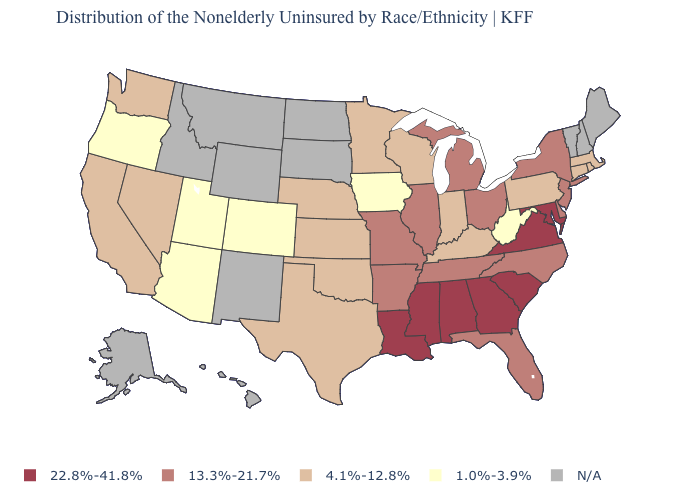Does West Virginia have the lowest value in the South?
Write a very short answer. Yes. Name the states that have a value in the range 4.1%-12.8%?
Concise answer only. California, Connecticut, Indiana, Kansas, Kentucky, Massachusetts, Minnesota, Nebraska, Nevada, Oklahoma, Pennsylvania, Rhode Island, Texas, Washington, Wisconsin. Which states have the lowest value in the West?
Be succinct. Arizona, Colorado, Oregon, Utah. What is the value of Wisconsin?
Concise answer only. 4.1%-12.8%. Does California have the lowest value in the West?
Be succinct. No. Which states have the highest value in the USA?
Concise answer only. Alabama, Georgia, Louisiana, Maryland, Mississippi, South Carolina, Virginia. What is the highest value in the South ?
Keep it brief. 22.8%-41.8%. Is the legend a continuous bar?
Write a very short answer. No. What is the value of Louisiana?
Give a very brief answer. 22.8%-41.8%. Name the states that have a value in the range N/A?
Be succinct. Alaska, Hawaii, Idaho, Maine, Montana, New Hampshire, New Mexico, North Dakota, South Dakota, Vermont, Wyoming. Which states have the lowest value in the USA?
Keep it brief. Arizona, Colorado, Iowa, Oregon, Utah, West Virginia. Name the states that have a value in the range 22.8%-41.8%?
Concise answer only. Alabama, Georgia, Louisiana, Maryland, Mississippi, South Carolina, Virginia. What is the value of South Carolina?
Quick response, please. 22.8%-41.8%. Which states have the lowest value in the USA?
Answer briefly. Arizona, Colorado, Iowa, Oregon, Utah, West Virginia. 